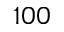Convert formula to latex. <formula><loc_0><loc_0><loc_500><loc_500>1 0 0</formula> 